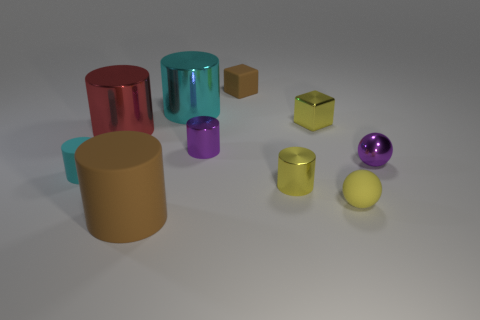Subtract all cyan shiny cylinders. How many cylinders are left? 5 Subtract all red cylinders. How many cylinders are left? 5 Subtract 3 cylinders. How many cylinders are left? 3 Add 6 small purple spheres. How many small purple spheres are left? 7 Add 5 yellow rubber spheres. How many yellow rubber spheres exist? 6 Subtract 0 red spheres. How many objects are left? 10 Subtract all cubes. How many objects are left? 8 Subtract all green spheres. Subtract all blue cylinders. How many spheres are left? 2 Subtract all purple cubes. How many cyan balls are left? 0 Subtract all large red cubes. Subtract all large red cylinders. How many objects are left? 9 